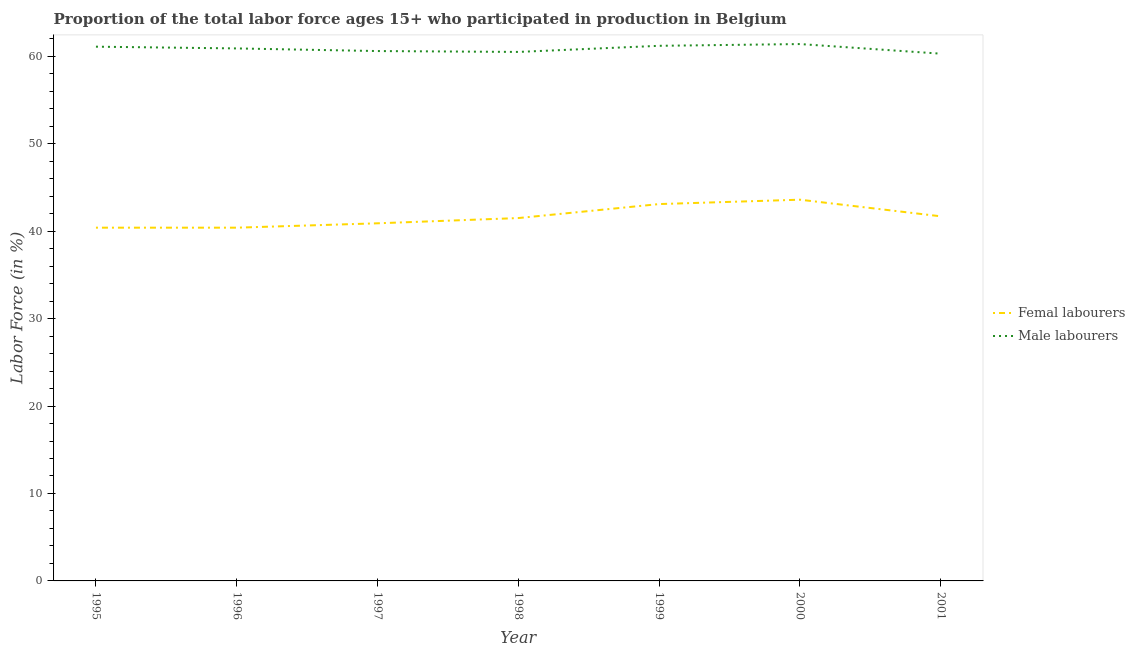How many different coloured lines are there?
Your response must be concise. 2. What is the percentage of female labor force in 2000?
Make the answer very short. 43.6. Across all years, what is the maximum percentage of male labour force?
Offer a terse response. 61.4. Across all years, what is the minimum percentage of female labor force?
Keep it short and to the point. 40.4. In which year was the percentage of female labor force maximum?
Offer a terse response. 2000. What is the total percentage of male labour force in the graph?
Give a very brief answer. 426. What is the difference between the percentage of female labor force in 1995 and that in 1999?
Offer a very short reply. -2.7. What is the difference between the percentage of male labour force in 1996 and the percentage of female labor force in 1998?
Your response must be concise. 19.4. What is the average percentage of male labour force per year?
Give a very brief answer. 60.86. In the year 2000, what is the difference between the percentage of female labor force and percentage of male labour force?
Provide a short and direct response. -17.8. What is the ratio of the percentage of male labour force in 1996 to that in 2000?
Offer a terse response. 0.99. Is the percentage of female labor force in 1996 less than that in 2001?
Keep it short and to the point. Yes. Is the difference between the percentage of female labor force in 1997 and 2001 greater than the difference between the percentage of male labour force in 1997 and 2001?
Give a very brief answer. No. What is the difference between the highest and the second highest percentage of male labour force?
Ensure brevity in your answer.  0.2. What is the difference between the highest and the lowest percentage of female labor force?
Provide a short and direct response. 3.2. In how many years, is the percentage of female labor force greater than the average percentage of female labor force taken over all years?
Your answer should be very brief. 3. Is the sum of the percentage of male labour force in 1995 and 2001 greater than the maximum percentage of female labor force across all years?
Give a very brief answer. Yes. How many years are there in the graph?
Provide a short and direct response. 7. What is the difference between two consecutive major ticks on the Y-axis?
Give a very brief answer. 10. Does the graph contain any zero values?
Offer a very short reply. No. What is the title of the graph?
Your answer should be very brief. Proportion of the total labor force ages 15+ who participated in production in Belgium. What is the Labor Force (in %) of Femal labourers in 1995?
Provide a short and direct response. 40.4. What is the Labor Force (in %) in Male labourers in 1995?
Provide a short and direct response. 61.1. What is the Labor Force (in %) of Femal labourers in 1996?
Provide a succinct answer. 40.4. What is the Labor Force (in %) in Male labourers in 1996?
Provide a short and direct response. 60.9. What is the Labor Force (in %) of Femal labourers in 1997?
Offer a very short reply. 40.9. What is the Labor Force (in %) of Male labourers in 1997?
Your answer should be very brief. 60.6. What is the Labor Force (in %) of Femal labourers in 1998?
Provide a short and direct response. 41.5. What is the Labor Force (in %) of Male labourers in 1998?
Provide a short and direct response. 60.5. What is the Labor Force (in %) of Femal labourers in 1999?
Provide a succinct answer. 43.1. What is the Labor Force (in %) in Male labourers in 1999?
Offer a terse response. 61.2. What is the Labor Force (in %) in Femal labourers in 2000?
Offer a very short reply. 43.6. What is the Labor Force (in %) of Male labourers in 2000?
Ensure brevity in your answer.  61.4. What is the Labor Force (in %) of Femal labourers in 2001?
Give a very brief answer. 41.7. What is the Labor Force (in %) in Male labourers in 2001?
Your answer should be compact. 60.3. Across all years, what is the maximum Labor Force (in %) in Femal labourers?
Make the answer very short. 43.6. Across all years, what is the maximum Labor Force (in %) of Male labourers?
Provide a short and direct response. 61.4. Across all years, what is the minimum Labor Force (in %) in Femal labourers?
Give a very brief answer. 40.4. Across all years, what is the minimum Labor Force (in %) in Male labourers?
Your response must be concise. 60.3. What is the total Labor Force (in %) of Femal labourers in the graph?
Make the answer very short. 291.6. What is the total Labor Force (in %) of Male labourers in the graph?
Your answer should be compact. 426. What is the difference between the Labor Force (in %) in Femal labourers in 1995 and that in 1996?
Make the answer very short. 0. What is the difference between the Labor Force (in %) in Femal labourers in 1995 and that in 1997?
Give a very brief answer. -0.5. What is the difference between the Labor Force (in %) in Male labourers in 1995 and that in 1997?
Keep it short and to the point. 0.5. What is the difference between the Labor Force (in %) in Femal labourers in 1995 and that in 1998?
Your response must be concise. -1.1. What is the difference between the Labor Force (in %) in Male labourers in 1995 and that in 2000?
Offer a terse response. -0.3. What is the difference between the Labor Force (in %) of Male labourers in 1995 and that in 2001?
Make the answer very short. 0.8. What is the difference between the Labor Force (in %) in Femal labourers in 1996 and that in 1997?
Your answer should be compact. -0.5. What is the difference between the Labor Force (in %) of Male labourers in 1996 and that in 1997?
Your answer should be very brief. 0.3. What is the difference between the Labor Force (in %) in Femal labourers in 1996 and that in 1999?
Make the answer very short. -2.7. What is the difference between the Labor Force (in %) in Male labourers in 1996 and that in 1999?
Your answer should be very brief. -0.3. What is the difference between the Labor Force (in %) in Femal labourers in 1996 and that in 2000?
Make the answer very short. -3.2. What is the difference between the Labor Force (in %) of Male labourers in 1996 and that in 2000?
Your response must be concise. -0.5. What is the difference between the Labor Force (in %) in Femal labourers in 1997 and that in 1998?
Give a very brief answer. -0.6. What is the difference between the Labor Force (in %) in Male labourers in 1997 and that in 1999?
Provide a succinct answer. -0.6. What is the difference between the Labor Force (in %) in Femal labourers in 1997 and that in 2000?
Make the answer very short. -2.7. What is the difference between the Labor Force (in %) of Male labourers in 1998 and that in 1999?
Ensure brevity in your answer.  -0.7. What is the difference between the Labor Force (in %) in Femal labourers in 1998 and that in 2000?
Provide a short and direct response. -2.1. What is the difference between the Labor Force (in %) of Male labourers in 1998 and that in 2000?
Your answer should be very brief. -0.9. What is the difference between the Labor Force (in %) of Femal labourers in 1998 and that in 2001?
Your answer should be very brief. -0.2. What is the difference between the Labor Force (in %) in Male labourers in 1998 and that in 2001?
Offer a very short reply. 0.2. What is the difference between the Labor Force (in %) in Male labourers in 1999 and that in 2000?
Provide a short and direct response. -0.2. What is the difference between the Labor Force (in %) in Male labourers in 2000 and that in 2001?
Ensure brevity in your answer.  1.1. What is the difference between the Labor Force (in %) of Femal labourers in 1995 and the Labor Force (in %) of Male labourers in 1996?
Your answer should be very brief. -20.5. What is the difference between the Labor Force (in %) of Femal labourers in 1995 and the Labor Force (in %) of Male labourers in 1997?
Your response must be concise. -20.2. What is the difference between the Labor Force (in %) of Femal labourers in 1995 and the Labor Force (in %) of Male labourers in 1998?
Your answer should be very brief. -20.1. What is the difference between the Labor Force (in %) in Femal labourers in 1995 and the Labor Force (in %) in Male labourers in 1999?
Give a very brief answer. -20.8. What is the difference between the Labor Force (in %) in Femal labourers in 1995 and the Labor Force (in %) in Male labourers in 2000?
Ensure brevity in your answer.  -21. What is the difference between the Labor Force (in %) in Femal labourers in 1995 and the Labor Force (in %) in Male labourers in 2001?
Provide a short and direct response. -19.9. What is the difference between the Labor Force (in %) of Femal labourers in 1996 and the Labor Force (in %) of Male labourers in 1997?
Ensure brevity in your answer.  -20.2. What is the difference between the Labor Force (in %) in Femal labourers in 1996 and the Labor Force (in %) in Male labourers in 1998?
Offer a very short reply. -20.1. What is the difference between the Labor Force (in %) in Femal labourers in 1996 and the Labor Force (in %) in Male labourers in 1999?
Your response must be concise. -20.8. What is the difference between the Labor Force (in %) of Femal labourers in 1996 and the Labor Force (in %) of Male labourers in 2001?
Offer a terse response. -19.9. What is the difference between the Labor Force (in %) of Femal labourers in 1997 and the Labor Force (in %) of Male labourers in 1998?
Give a very brief answer. -19.6. What is the difference between the Labor Force (in %) of Femal labourers in 1997 and the Labor Force (in %) of Male labourers in 1999?
Provide a succinct answer. -20.3. What is the difference between the Labor Force (in %) in Femal labourers in 1997 and the Labor Force (in %) in Male labourers in 2000?
Ensure brevity in your answer.  -20.5. What is the difference between the Labor Force (in %) in Femal labourers in 1997 and the Labor Force (in %) in Male labourers in 2001?
Ensure brevity in your answer.  -19.4. What is the difference between the Labor Force (in %) of Femal labourers in 1998 and the Labor Force (in %) of Male labourers in 1999?
Provide a short and direct response. -19.7. What is the difference between the Labor Force (in %) in Femal labourers in 1998 and the Labor Force (in %) in Male labourers in 2000?
Your answer should be compact. -19.9. What is the difference between the Labor Force (in %) of Femal labourers in 1998 and the Labor Force (in %) of Male labourers in 2001?
Offer a very short reply. -18.8. What is the difference between the Labor Force (in %) in Femal labourers in 1999 and the Labor Force (in %) in Male labourers in 2000?
Offer a very short reply. -18.3. What is the difference between the Labor Force (in %) in Femal labourers in 1999 and the Labor Force (in %) in Male labourers in 2001?
Ensure brevity in your answer.  -17.2. What is the difference between the Labor Force (in %) in Femal labourers in 2000 and the Labor Force (in %) in Male labourers in 2001?
Provide a succinct answer. -16.7. What is the average Labor Force (in %) in Femal labourers per year?
Provide a short and direct response. 41.66. What is the average Labor Force (in %) in Male labourers per year?
Make the answer very short. 60.86. In the year 1995, what is the difference between the Labor Force (in %) of Femal labourers and Labor Force (in %) of Male labourers?
Your answer should be very brief. -20.7. In the year 1996, what is the difference between the Labor Force (in %) in Femal labourers and Labor Force (in %) in Male labourers?
Offer a terse response. -20.5. In the year 1997, what is the difference between the Labor Force (in %) in Femal labourers and Labor Force (in %) in Male labourers?
Offer a very short reply. -19.7. In the year 1998, what is the difference between the Labor Force (in %) in Femal labourers and Labor Force (in %) in Male labourers?
Your answer should be compact. -19. In the year 1999, what is the difference between the Labor Force (in %) of Femal labourers and Labor Force (in %) of Male labourers?
Offer a very short reply. -18.1. In the year 2000, what is the difference between the Labor Force (in %) of Femal labourers and Labor Force (in %) of Male labourers?
Offer a terse response. -17.8. In the year 2001, what is the difference between the Labor Force (in %) of Femal labourers and Labor Force (in %) of Male labourers?
Make the answer very short. -18.6. What is the ratio of the Labor Force (in %) in Femal labourers in 1995 to that in 1997?
Give a very brief answer. 0.99. What is the ratio of the Labor Force (in %) of Male labourers in 1995 to that in 1997?
Give a very brief answer. 1.01. What is the ratio of the Labor Force (in %) of Femal labourers in 1995 to that in 1998?
Offer a terse response. 0.97. What is the ratio of the Labor Force (in %) in Male labourers in 1995 to that in 1998?
Provide a succinct answer. 1.01. What is the ratio of the Labor Force (in %) of Femal labourers in 1995 to that in 1999?
Give a very brief answer. 0.94. What is the ratio of the Labor Force (in %) in Male labourers in 1995 to that in 1999?
Ensure brevity in your answer.  1. What is the ratio of the Labor Force (in %) of Femal labourers in 1995 to that in 2000?
Give a very brief answer. 0.93. What is the ratio of the Labor Force (in %) in Male labourers in 1995 to that in 2000?
Your answer should be very brief. 1. What is the ratio of the Labor Force (in %) in Femal labourers in 1995 to that in 2001?
Offer a terse response. 0.97. What is the ratio of the Labor Force (in %) of Male labourers in 1995 to that in 2001?
Offer a terse response. 1.01. What is the ratio of the Labor Force (in %) of Femal labourers in 1996 to that in 1997?
Ensure brevity in your answer.  0.99. What is the ratio of the Labor Force (in %) in Male labourers in 1996 to that in 1997?
Offer a terse response. 1. What is the ratio of the Labor Force (in %) in Femal labourers in 1996 to that in 1998?
Your response must be concise. 0.97. What is the ratio of the Labor Force (in %) of Male labourers in 1996 to that in 1998?
Offer a very short reply. 1.01. What is the ratio of the Labor Force (in %) of Femal labourers in 1996 to that in 1999?
Your answer should be very brief. 0.94. What is the ratio of the Labor Force (in %) of Male labourers in 1996 to that in 1999?
Make the answer very short. 1. What is the ratio of the Labor Force (in %) in Femal labourers in 1996 to that in 2000?
Provide a short and direct response. 0.93. What is the ratio of the Labor Force (in %) in Femal labourers in 1996 to that in 2001?
Offer a terse response. 0.97. What is the ratio of the Labor Force (in %) of Femal labourers in 1997 to that in 1998?
Your answer should be very brief. 0.99. What is the ratio of the Labor Force (in %) of Femal labourers in 1997 to that in 1999?
Your answer should be compact. 0.95. What is the ratio of the Labor Force (in %) of Male labourers in 1997 to that in 1999?
Keep it short and to the point. 0.99. What is the ratio of the Labor Force (in %) in Femal labourers in 1997 to that in 2000?
Your answer should be very brief. 0.94. What is the ratio of the Labor Force (in %) in Male labourers in 1997 to that in 2000?
Ensure brevity in your answer.  0.99. What is the ratio of the Labor Force (in %) of Femal labourers in 1997 to that in 2001?
Your answer should be very brief. 0.98. What is the ratio of the Labor Force (in %) in Femal labourers in 1998 to that in 1999?
Provide a succinct answer. 0.96. What is the ratio of the Labor Force (in %) in Male labourers in 1998 to that in 1999?
Your answer should be very brief. 0.99. What is the ratio of the Labor Force (in %) in Femal labourers in 1998 to that in 2000?
Provide a succinct answer. 0.95. What is the ratio of the Labor Force (in %) in Male labourers in 1998 to that in 2000?
Provide a succinct answer. 0.99. What is the ratio of the Labor Force (in %) of Male labourers in 1998 to that in 2001?
Make the answer very short. 1. What is the ratio of the Labor Force (in %) in Male labourers in 1999 to that in 2000?
Ensure brevity in your answer.  1. What is the ratio of the Labor Force (in %) in Femal labourers in 1999 to that in 2001?
Your answer should be compact. 1.03. What is the ratio of the Labor Force (in %) in Male labourers in 1999 to that in 2001?
Provide a short and direct response. 1.01. What is the ratio of the Labor Force (in %) of Femal labourers in 2000 to that in 2001?
Your answer should be very brief. 1.05. What is the ratio of the Labor Force (in %) in Male labourers in 2000 to that in 2001?
Keep it short and to the point. 1.02. What is the difference between the highest and the second highest Labor Force (in %) in Male labourers?
Provide a short and direct response. 0.2. What is the difference between the highest and the lowest Labor Force (in %) of Male labourers?
Make the answer very short. 1.1. 